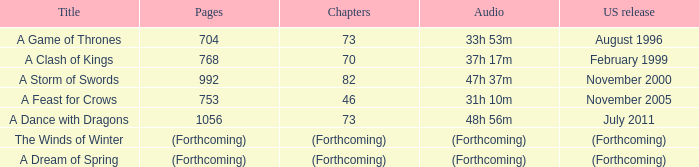Which title has a US release of august 1996? A Game of Thrones. 